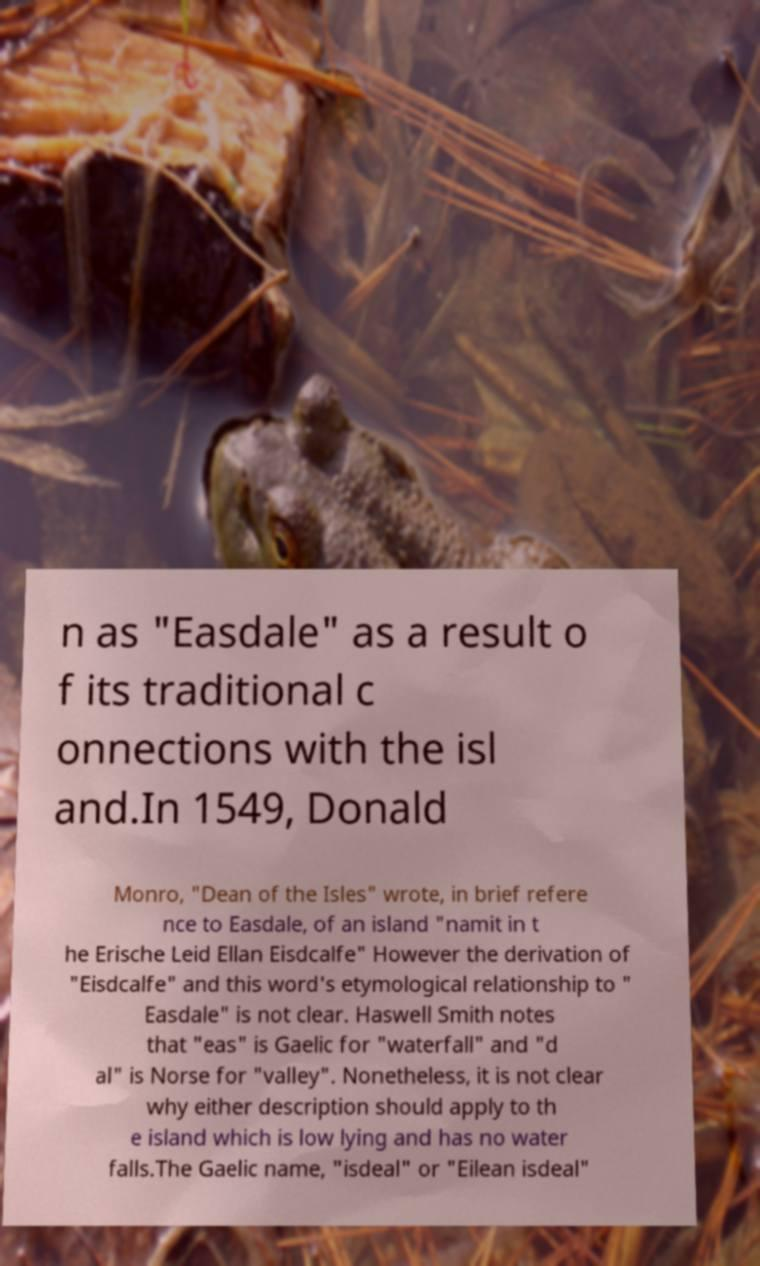Please identify and transcribe the text found in this image. n as "Easdale" as a result o f its traditional c onnections with the isl and.In 1549, Donald Monro, "Dean of the Isles" wrote, in brief refere nce to Easdale, of an island "namit in t he Erische Leid Ellan Eisdcalfe" However the derivation of "Eisdcalfe" and this word's etymological relationship to " Easdale" is not clear. Haswell Smith notes that "eas" is Gaelic for "waterfall" and "d al" is Norse for "valley". Nonetheless, it is not clear why either description should apply to th e island which is low lying and has no water falls.The Gaelic name, "isdeal" or "Eilean isdeal" 